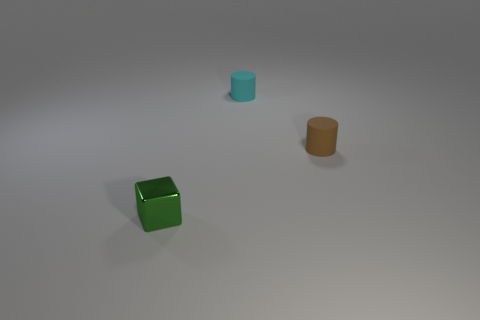What number of small cyan rubber objects have the same shape as the small brown rubber object?
Your response must be concise. 1. There is a small object on the left side of the tiny cyan rubber cylinder; does it have the same shape as the small matte thing that is on the left side of the brown matte cylinder?
Your response must be concise. No. What number of objects are small objects or things that are right of the tiny cube?
Keep it short and to the point. 3. What number of other cyan rubber cylinders have the same size as the cyan cylinder?
Provide a succinct answer. 0. What number of cyan objects are either tiny matte objects or small metallic blocks?
Keep it short and to the point. 1. What is the shape of the object that is behind the small rubber thing that is in front of the tiny cyan thing?
Your answer should be very brief. Cylinder. There is a green shiny object that is the same size as the brown rubber cylinder; what shape is it?
Your answer should be very brief. Cube. Are there the same number of tiny cyan objects on the left side of the tiny green metallic cube and metal things that are to the right of the small cyan cylinder?
Provide a short and direct response. Yes. There is a small cyan thing; does it have the same shape as the object that is left of the small cyan matte cylinder?
Offer a terse response. No. How many other things are there of the same material as the tiny block?
Offer a very short reply. 0. 